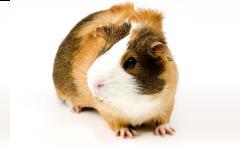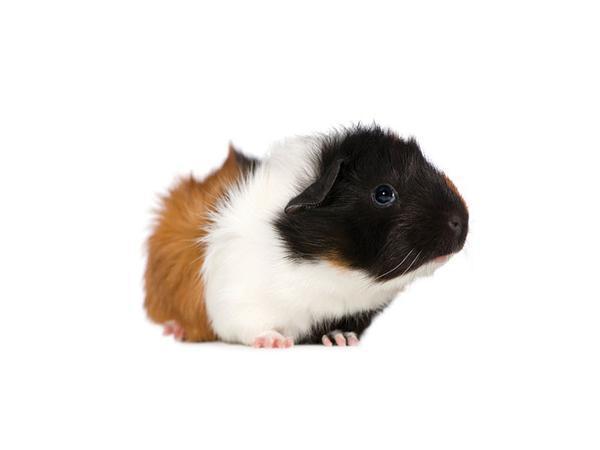The first image is the image on the left, the second image is the image on the right. Considering the images on both sides, is "There are two hamsters in total." valid? Answer yes or no. Yes. 